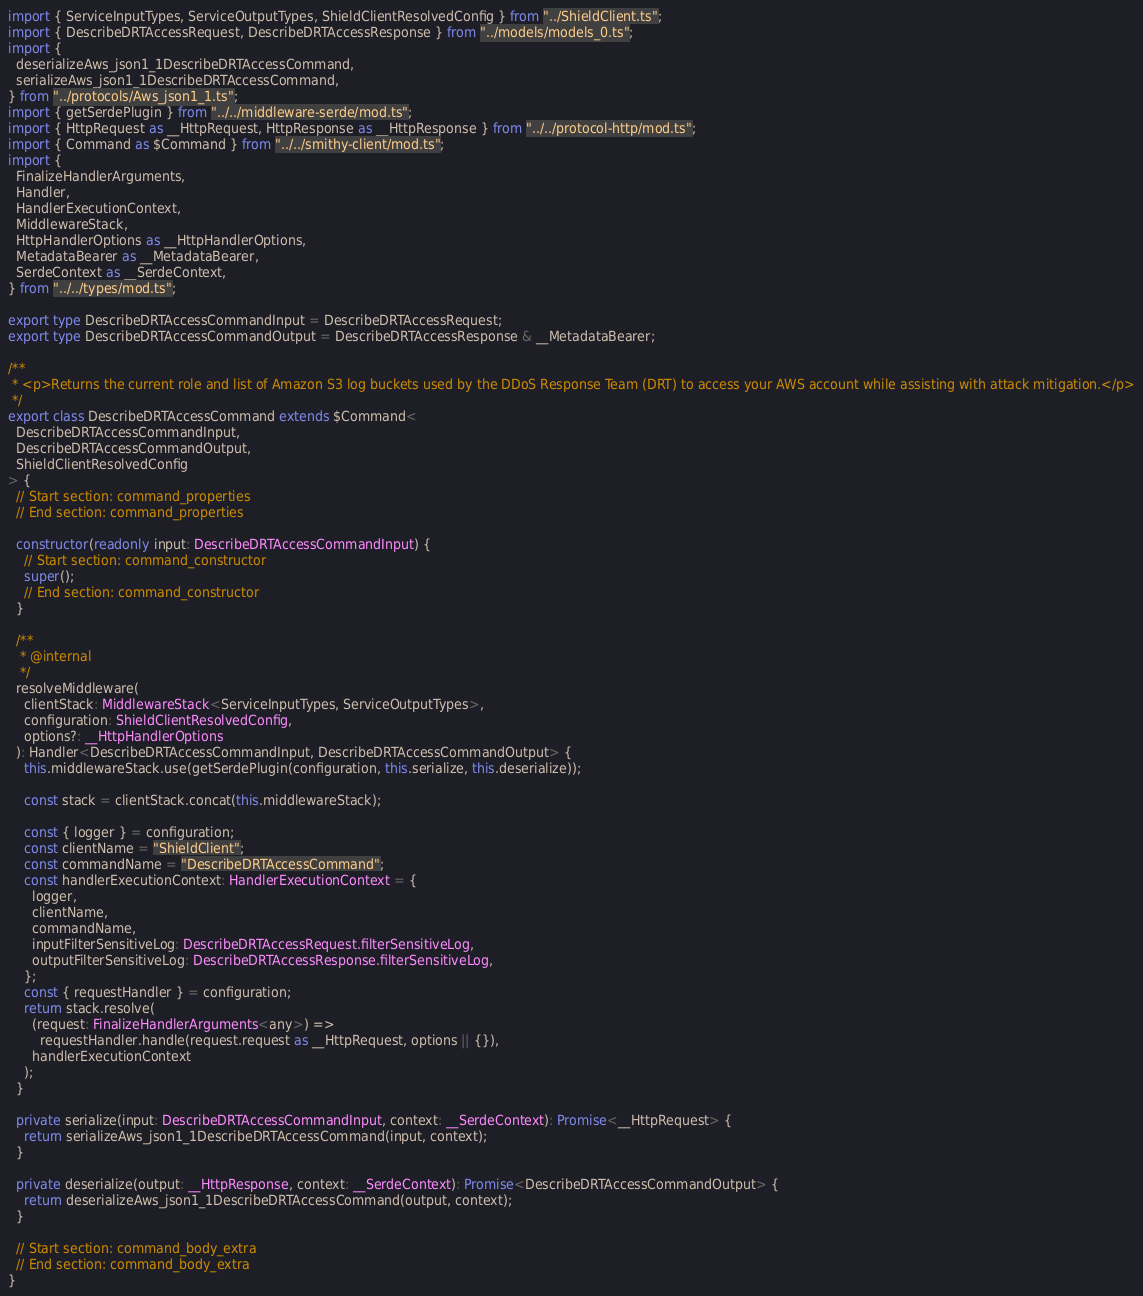<code> <loc_0><loc_0><loc_500><loc_500><_TypeScript_>import { ServiceInputTypes, ServiceOutputTypes, ShieldClientResolvedConfig } from "../ShieldClient.ts";
import { DescribeDRTAccessRequest, DescribeDRTAccessResponse } from "../models/models_0.ts";
import {
  deserializeAws_json1_1DescribeDRTAccessCommand,
  serializeAws_json1_1DescribeDRTAccessCommand,
} from "../protocols/Aws_json1_1.ts";
import { getSerdePlugin } from "../../middleware-serde/mod.ts";
import { HttpRequest as __HttpRequest, HttpResponse as __HttpResponse } from "../../protocol-http/mod.ts";
import { Command as $Command } from "../../smithy-client/mod.ts";
import {
  FinalizeHandlerArguments,
  Handler,
  HandlerExecutionContext,
  MiddlewareStack,
  HttpHandlerOptions as __HttpHandlerOptions,
  MetadataBearer as __MetadataBearer,
  SerdeContext as __SerdeContext,
} from "../../types/mod.ts";

export type DescribeDRTAccessCommandInput = DescribeDRTAccessRequest;
export type DescribeDRTAccessCommandOutput = DescribeDRTAccessResponse & __MetadataBearer;

/**
 * <p>Returns the current role and list of Amazon S3 log buckets used by the DDoS Response Team (DRT) to access your AWS account while assisting with attack mitigation.</p>
 */
export class DescribeDRTAccessCommand extends $Command<
  DescribeDRTAccessCommandInput,
  DescribeDRTAccessCommandOutput,
  ShieldClientResolvedConfig
> {
  // Start section: command_properties
  // End section: command_properties

  constructor(readonly input: DescribeDRTAccessCommandInput) {
    // Start section: command_constructor
    super();
    // End section: command_constructor
  }

  /**
   * @internal
   */
  resolveMiddleware(
    clientStack: MiddlewareStack<ServiceInputTypes, ServiceOutputTypes>,
    configuration: ShieldClientResolvedConfig,
    options?: __HttpHandlerOptions
  ): Handler<DescribeDRTAccessCommandInput, DescribeDRTAccessCommandOutput> {
    this.middlewareStack.use(getSerdePlugin(configuration, this.serialize, this.deserialize));

    const stack = clientStack.concat(this.middlewareStack);

    const { logger } = configuration;
    const clientName = "ShieldClient";
    const commandName = "DescribeDRTAccessCommand";
    const handlerExecutionContext: HandlerExecutionContext = {
      logger,
      clientName,
      commandName,
      inputFilterSensitiveLog: DescribeDRTAccessRequest.filterSensitiveLog,
      outputFilterSensitiveLog: DescribeDRTAccessResponse.filterSensitiveLog,
    };
    const { requestHandler } = configuration;
    return stack.resolve(
      (request: FinalizeHandlerArguments<any>) =>
        requestHandler.handle(request.request as __HttpRequest, options || {}),
      handlerExecutionContext
    );
  }

  private serialize(input: DescribeDRTAccessCommandInput, context: __SerdeContext): Promise<__HttpRequest> {
    return serializeAws_json1_1DescribeDRTAccessCommand(input, context);
  }

  private deserialize(output: __HttpResponse, context: __SerdeContext): Promise<DescribeDRTAccessCommandOutput> {
    return deserializeAws_json1_1DescribeDRTAccessCommand(output, context);
  }

  // Start section: command_body_extra
  // End section: command_body_extra
}
</code> 